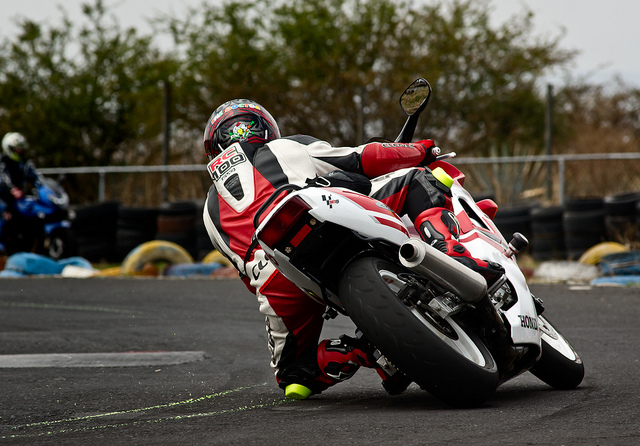Please transcribe the text information in this image. 100 